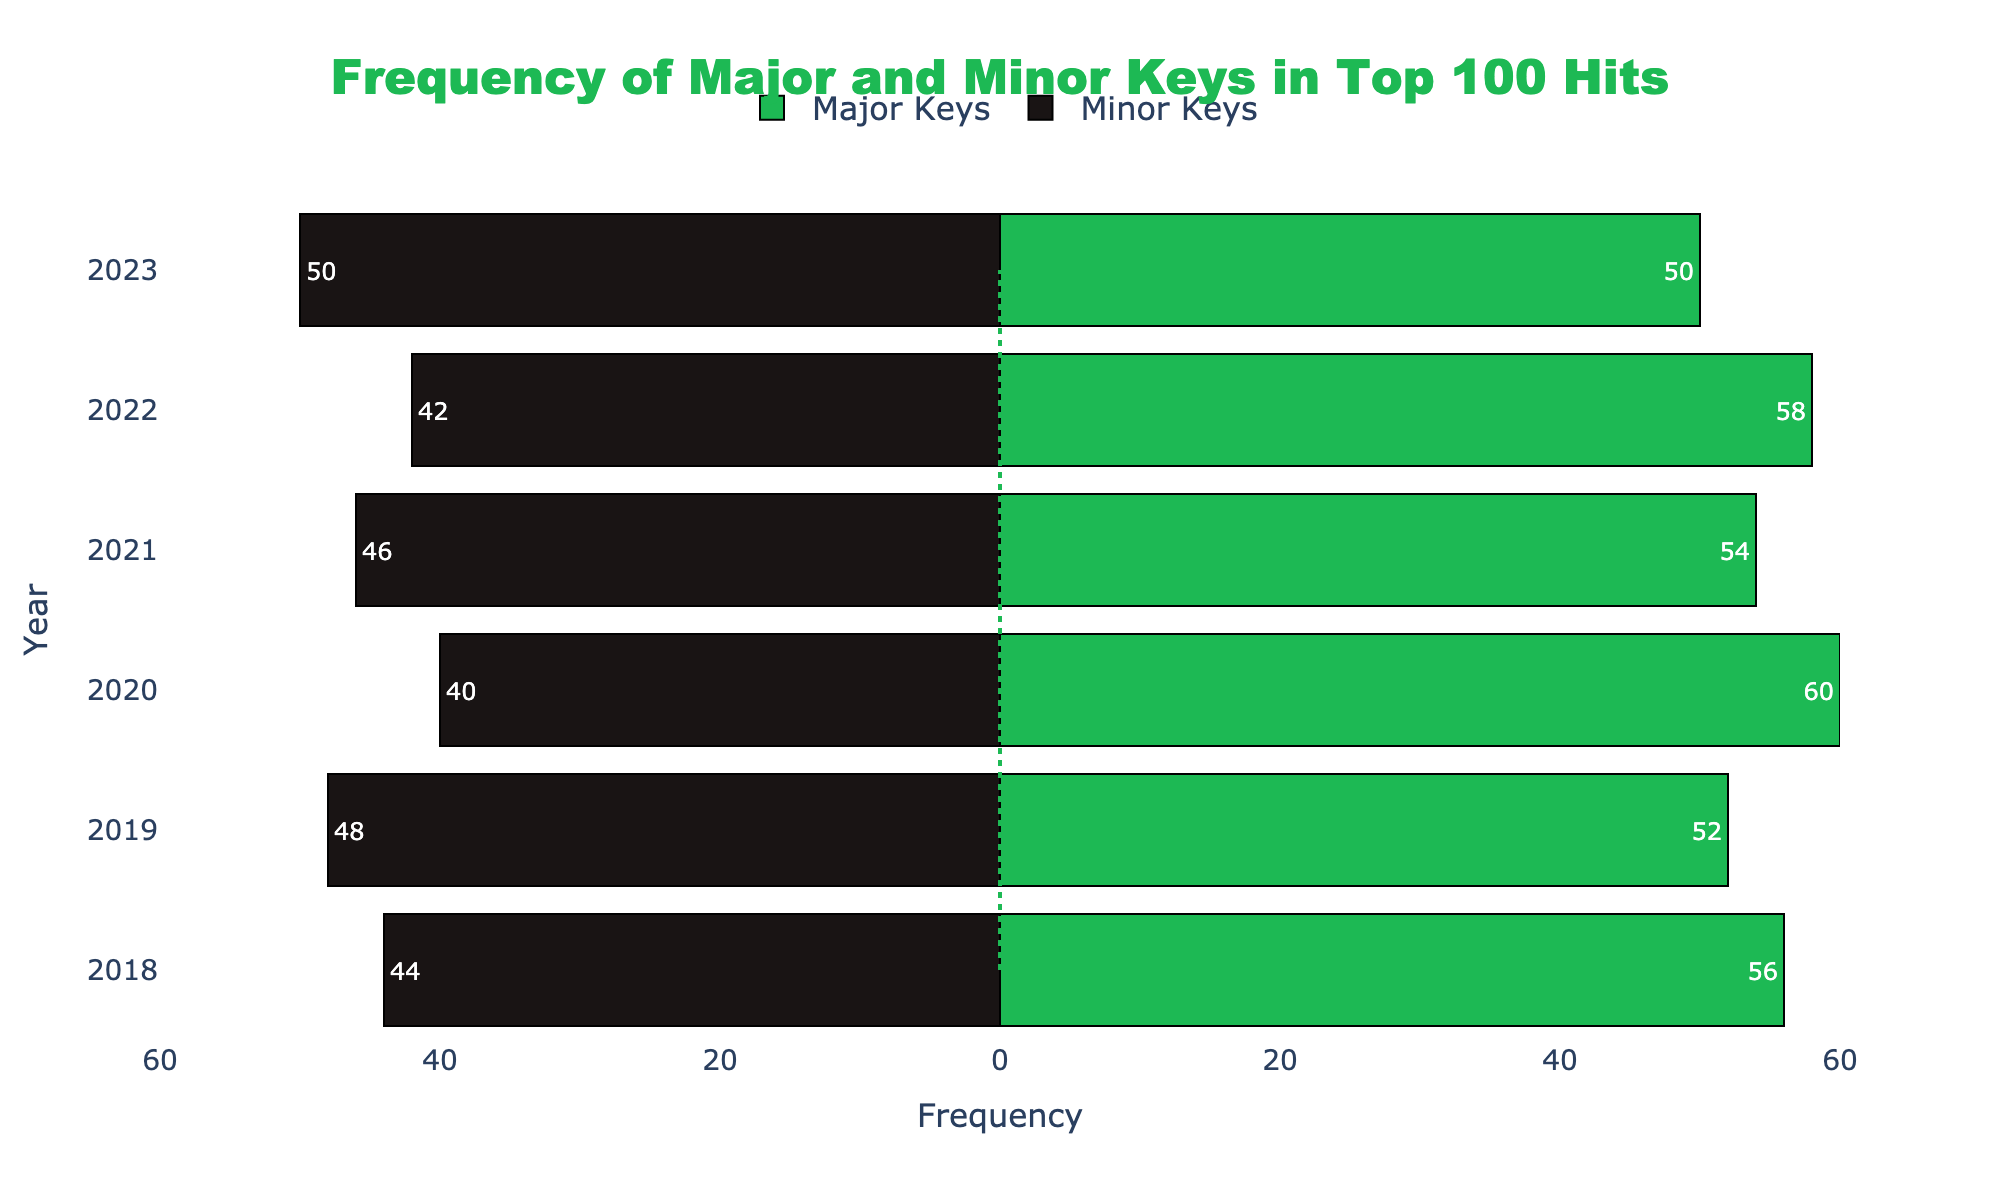What's the frequency of major keys in 2020? From the diverging bar chart, find the bar corresponding to the year 2020 and check the length and label of the green bar (for major keys). The label shows 60.
Answer: 60 Which year had an equal number of major and minor keys? Look for the year where the green and black bars are of equal length, which can be seen for the year 2023, where both bars are at 50.
Answer: 2023 What's the total frequency of songs in major keys from 2018 to 2023? Sum the values of the green bars for each year from 2018 to 2023: (56 + 52 + 60 + 54 + 58 + 50). This gives a total of 330.
Answer: 330 Are there more major or minor keys in 2021? Compare the lengths of the green and black bars for the year 2021. The green bar (major keys) is longer with a value of 54, while the black bar (minor keys) has a value of 46. Therefore, there are more major keys.
Answer: Major keys Which year had the least frequency of minor keys? Analyze the lengths of the black bars and find the year with the shortest bar, which corresponds to 2020 with a value of 40.
Answer: 2020 What is the average frequency of minor keys across all years? Sum the values of the black bars for all years (44 + 48 + 40 + 46 + 42 + 50) which gives 270, then divide by the number of years (6). The average is 270/6 = 45.
Answer: 45 Which year showed the greatest difference between major and minor keys? Find the year where the difference between the green and black bars is the highest. In 2020, the major keys are 60 and minor keys are 40, giving a difference of 20, which is the largest difference among the years.
Answer: 2020 If we combine the data for 2019 and 2022, which key type appears more frequently? Add the values for major and minor keys in 2019 and 2022. Major keys: 52 (2019) + 58 (2022) = 110. Minor keys: 48 (2019) + 42 (2022) = 90. Therefore, major keys appear more frequently.
Answer: Major keys 